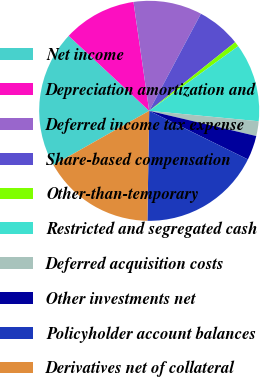Convert chart to OTSL. <chart><loc_0><loc_0><loc_500><loc_500><pie_chart><fcel>Net income<fcel>Depreciation amortization and<fcel>Deferred income tax expense<fcel>Share-based compensation<fcel>Other-than-temporary<fcel>Restricted and segregated cash<fcel>Deferred acquisition costs<fcel>Other investments net<fcel>Policyholder account balances<fcel>Derivatives net of collateral<nl><fcel>20.13%<fcel>10.79%<fcel>10.07%<fcel>6.48%<fcel>0.73%<fcel>11.51%<fcel>2.17%<fcel>3.6%<fcel>17.98%<fcel>16.54%<nl></chart> 